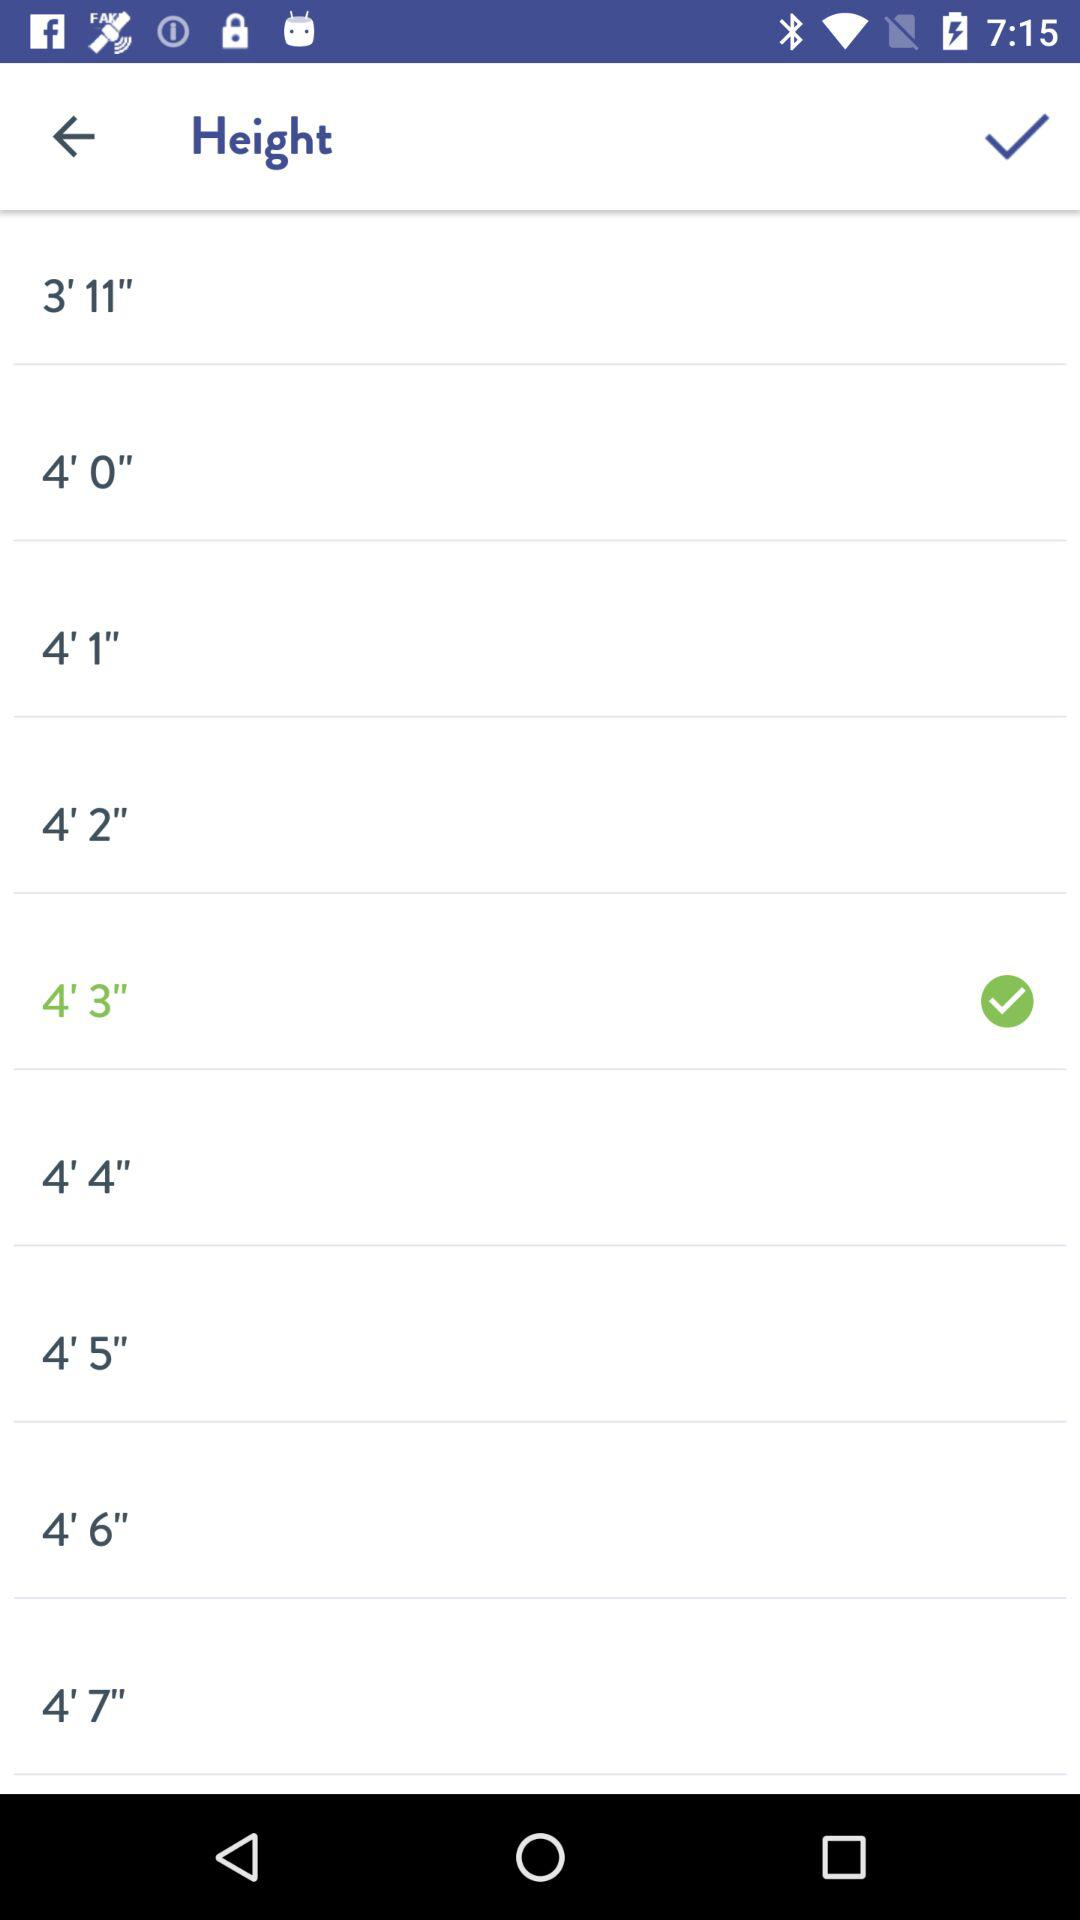What is the selected height? The selected height is 4 feet 3 inches. 